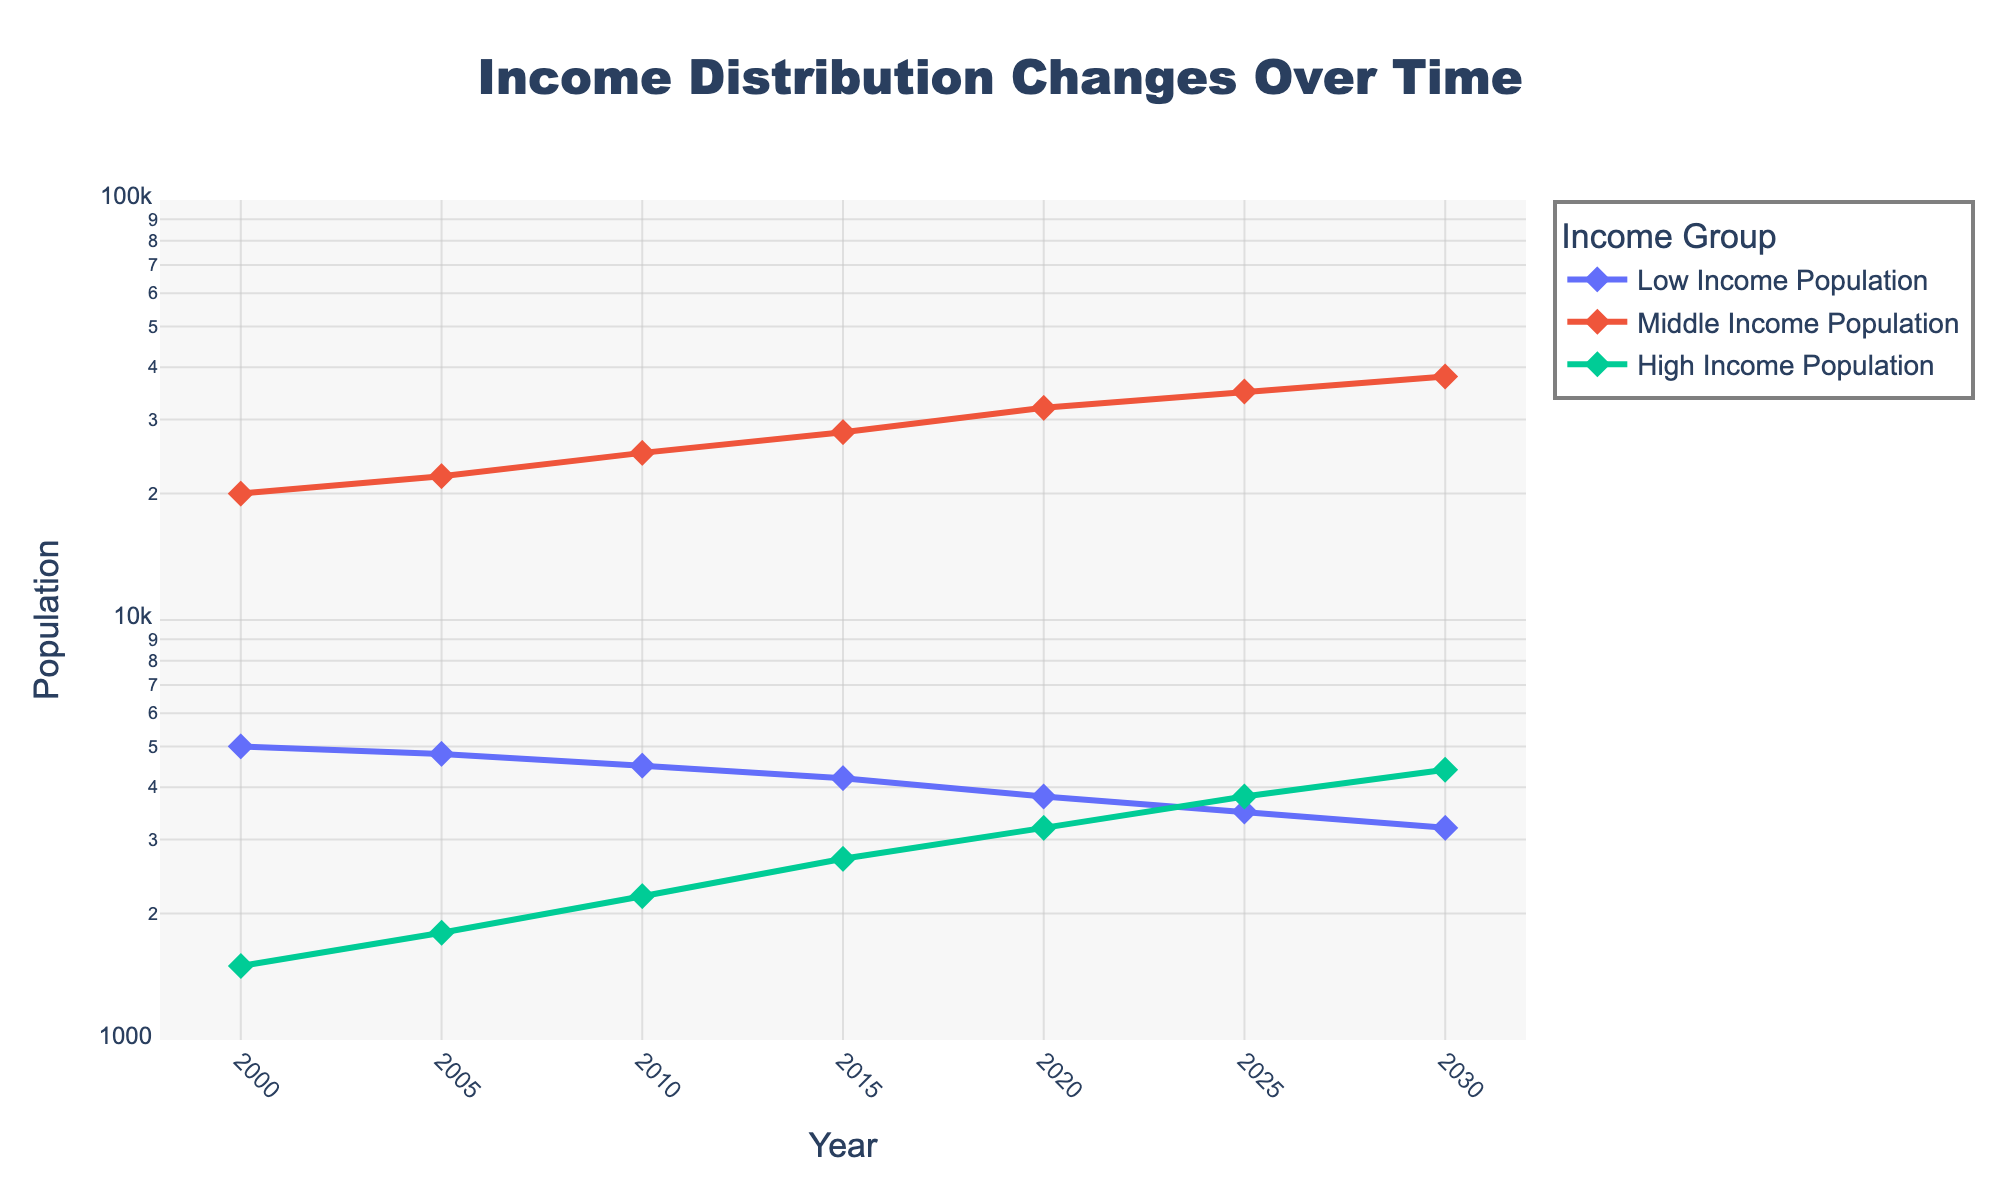What is the title of the plot? The title is located at the top center of the plot and represents the main focus of the visual. From the data provided, the title of the plot is "Income Distribution Changes Over Time".
Answer: Income Distribution Changes Over Time What is the population of the High Income group in the year 2020? Look for the point where the High Income Population intersects with the year 2020 on the x-axis. According to the data, it is 3200.
Answer: 3200 Which income group had the highest population increase between 2000 and 2030? Compare the populations of each income group in 2000 and 2030. The Middle Income Population increased from 20000 to 38000, which is the highest increase compared to other groups.
Answer: Middle Income Population What is the trend of the Low Income Population over the years? Examine the line representing the Low Income Population across the years. The trend shows a consistent decrease from 5000 in 2000 to 3200 in 2030.
Answer: Decreasing How does the growth rate of the High Income group between 2000 and 2030 compare to the Low Income group? Calculate the growth rate (final - initial)/initial for both groups: High Income: (4400 - 1500)/1500 = 1.93; Low Income: (3200 - 5000)/5000 = -0.36. The High Income group grew at a significantly higher rate than the Low Income group.
Answer: The High Income group grew faster In which year did the Middle Income Population reach 25000? Identify the data point on the plot where the Middle Income Population line intersects 25000 on the y-axis. According to the data, it is in the year 2010.
Answer: 2010 What can you say about the trend of the total population across all groups from 2000 to 2030? Add the populations of Low, Middle, and High Income groups for the years 2000 and 2030. 2000: 5000+20000+1500=26500; 2030: 3200+38000+4400=45600. The total population increased over time.
Answer: Increasing By what factor did the High Income Population increase between 2000 and 2030? The population in 2000 is 1500 and in 2030 is 4400. Divide the final population by the initial population: 4400/1500 = 2.93.
Answer: 2.93 How did the population distribution among the income groups change from 2005 to 2025? Compare the populations in 2005 and 2025: Low Income decreased from 4800 to 3500, Middle Income increased from 22000 to 35000, and High Income increased from 1800 to 3800.
Answer: Low Income decreased, Middle and High Income increased 